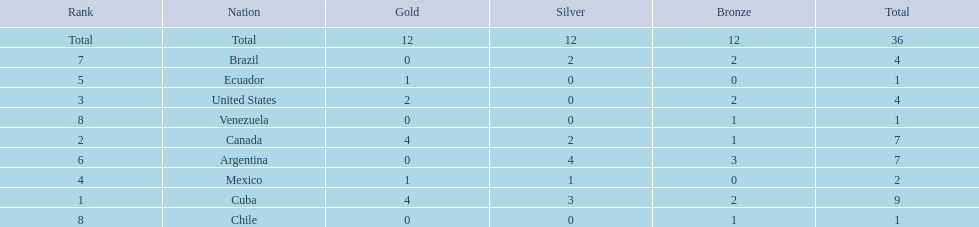What countries participated? Cuba, 4, 3, 2, Canada, 4, 2, 1, United States, 2, 0, 2, Mexico, 1, 1, 0, Ecuador, 1, 0, 0, Argentina, 0, 4, 3, Brazil, 0, 2, 2, Chile, 0, 0, 1, Venezuela, 0, 0, 1. What countries won 1 gold Mexico, 1, 1, 0, Ecuador, 1, 0, 0. What country above also won no silver? Ecuador. 